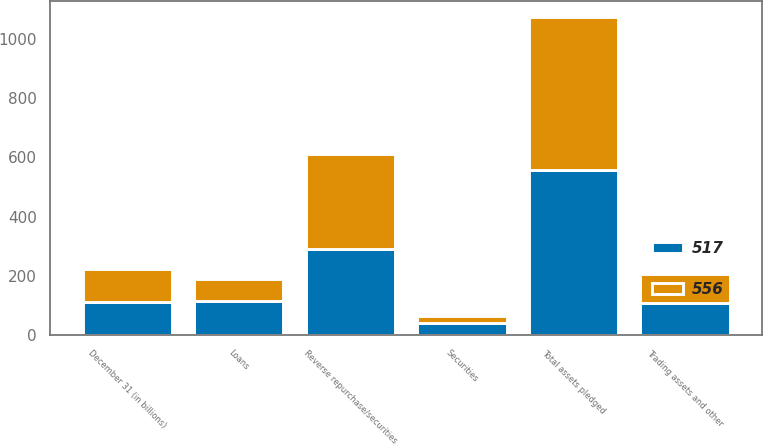<chart> <loc_0><loc_0><loc_500><loc_500><stacked_bar_chart><ecel><fcel>December 31 (in billions)<fcel>Reverse repurchase/securities<fcel>Securities<fcel>Loans<fcel>Trading assets and other<fcel>Total assets pledged<nl><fcel>517<fcel>112.5<fcel>291<fcel>40<fcel>117<fcel>108<fcel>556<nl><fcel>556<fcel>112.5<fcel>320<fcel>24<fcel>74<fcel>99<fcel>517<nl></chart> 